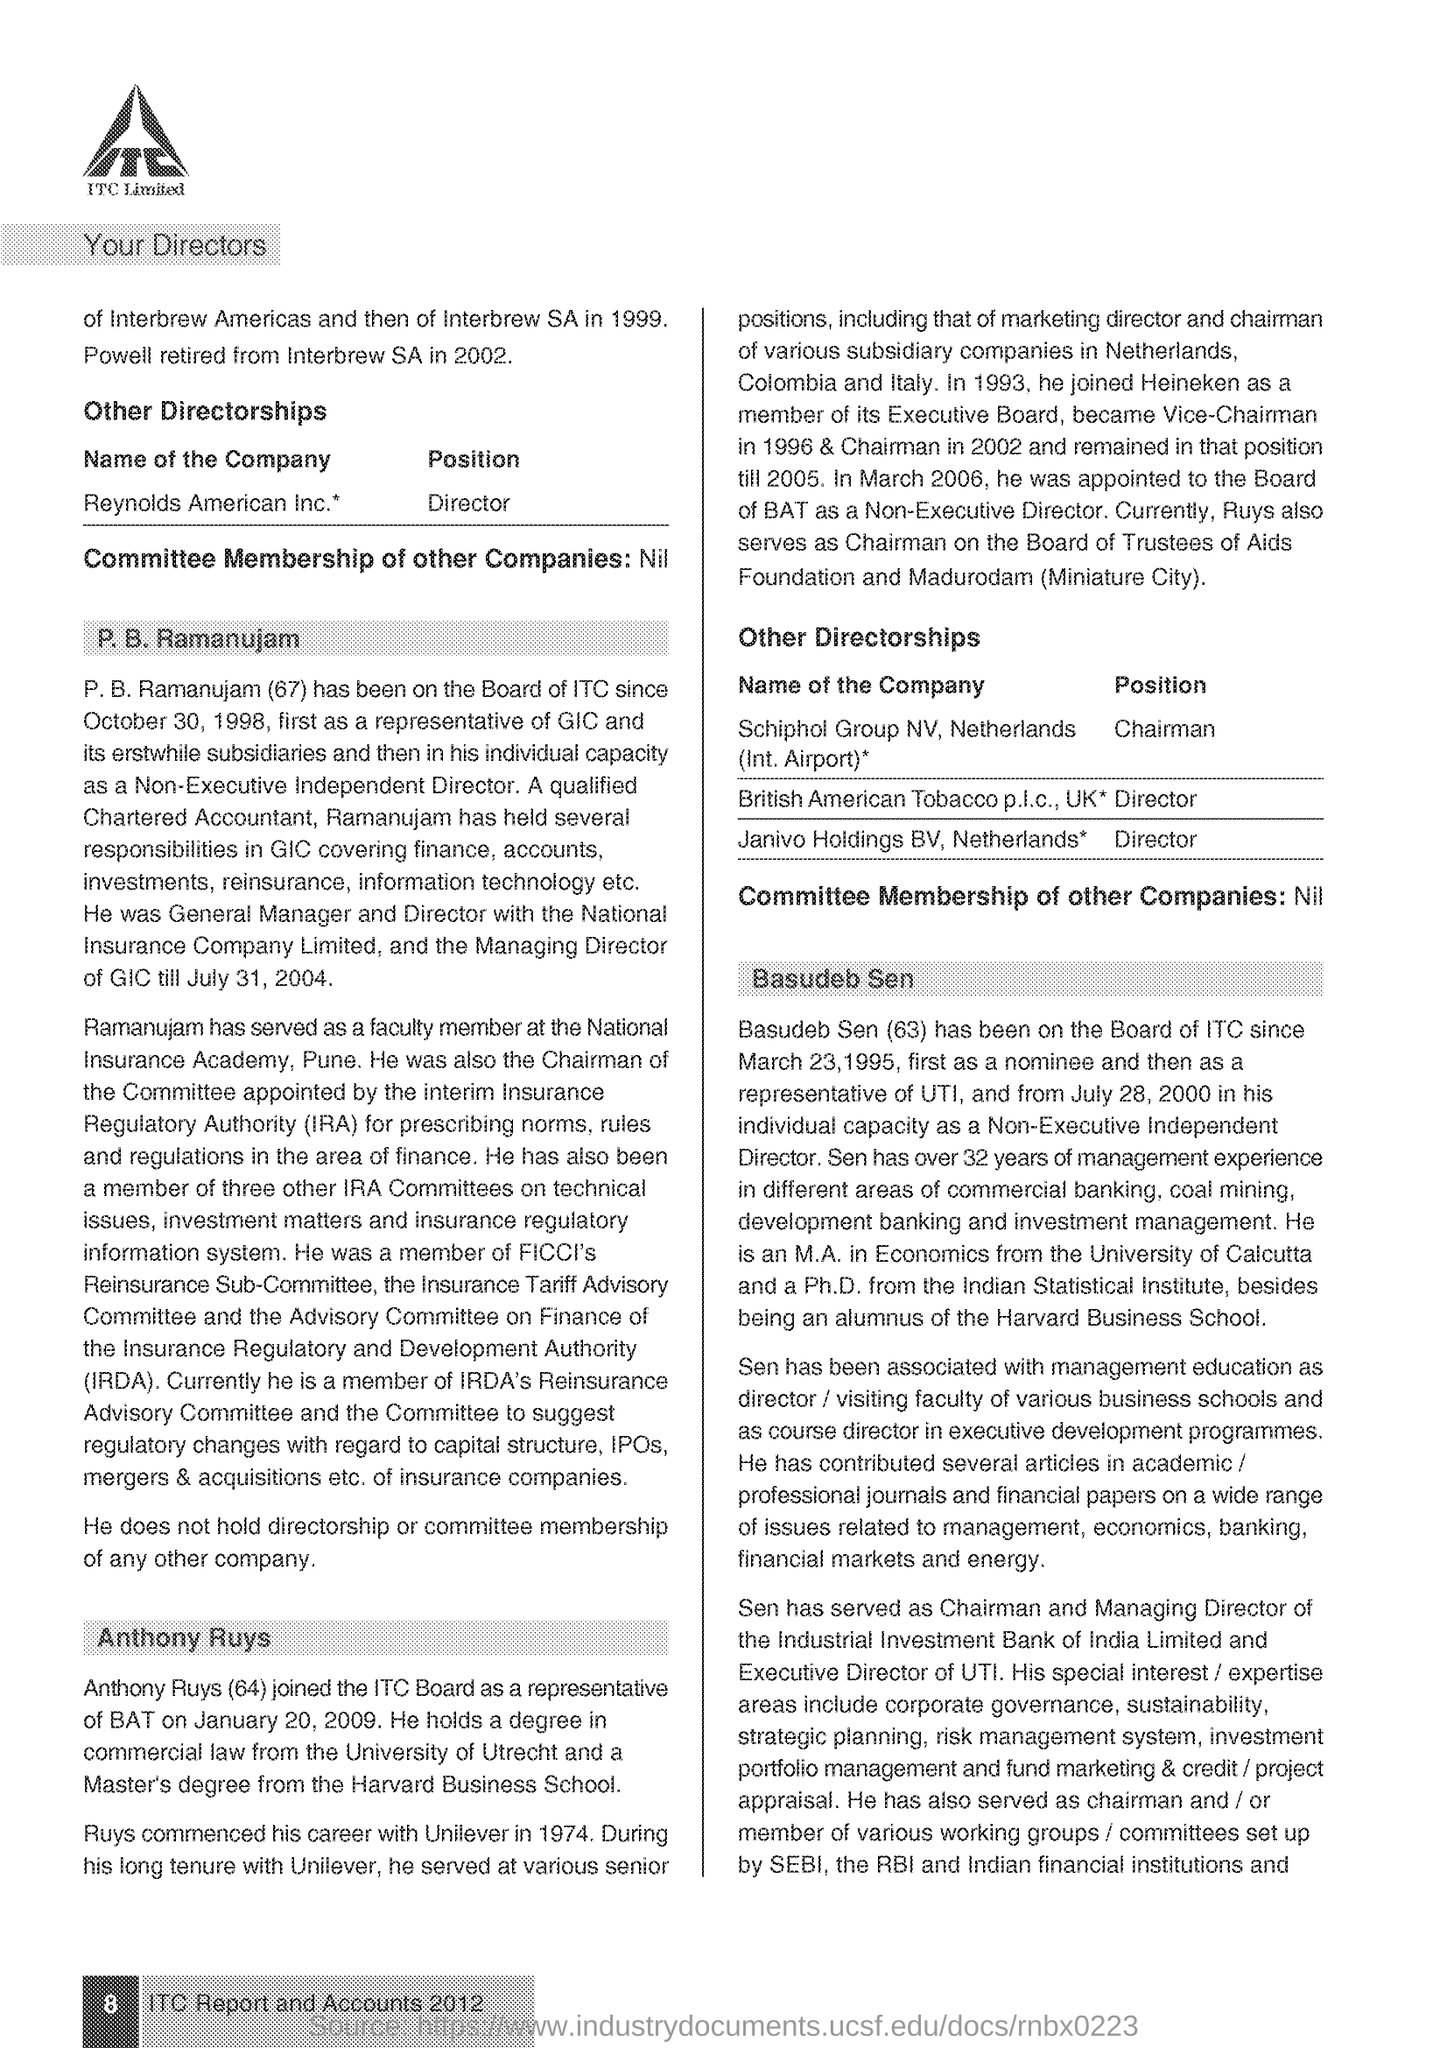What is the fullform of IRA ?
Make the answer very short. Insurance Regulatory Authority. What is the IRDA ?
Your response must be concise. Insurance Regulatory and Development Authority. 